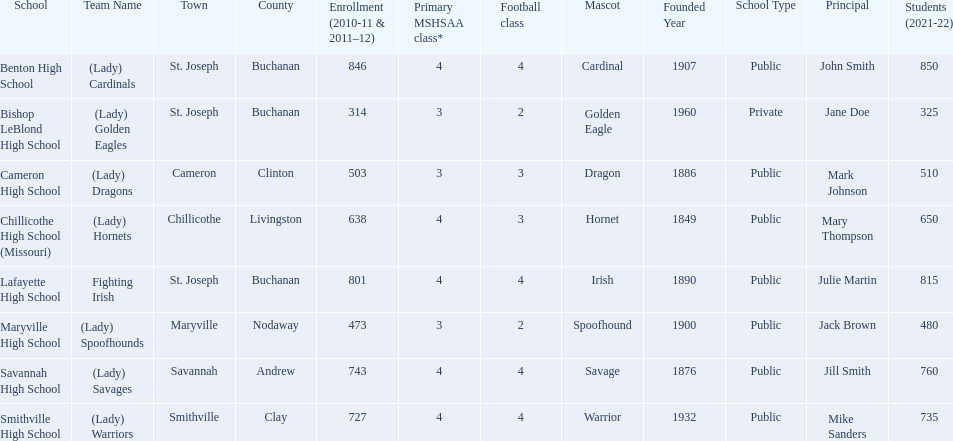What school has 3 football classes but only has 638 student enrollment? Chillicothe High School (Missouri). 